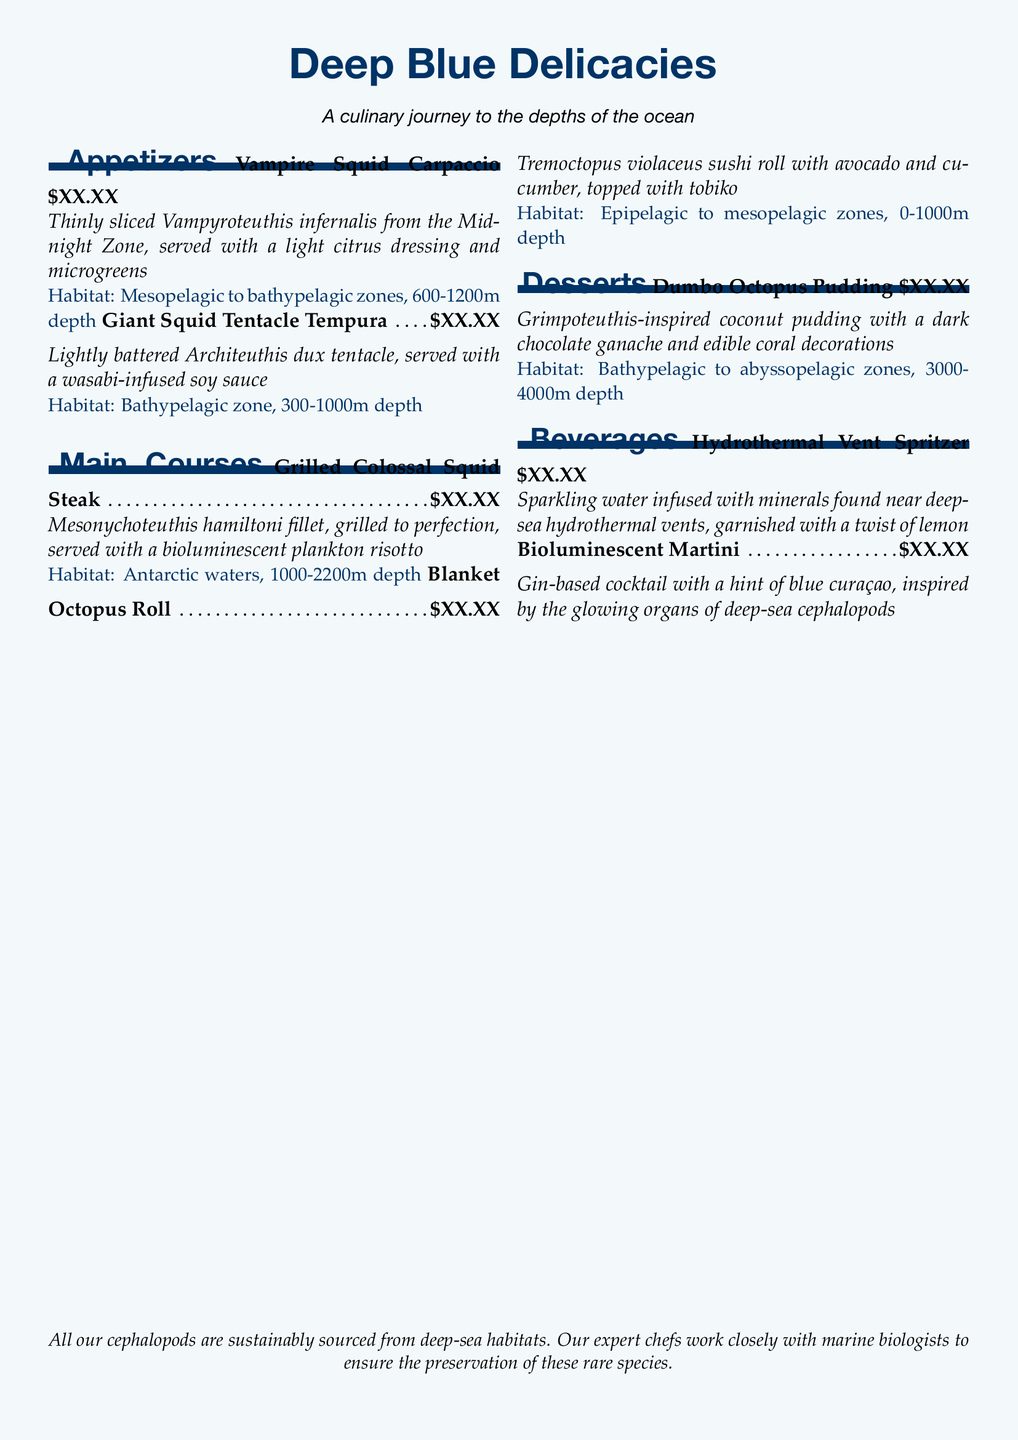What is the first appetizer listed on the menu? The first appetizer listed is "Vampire Squid Carpaccio."
Answer: Vampire Squid Carpaccio What is the primary habitat of the Giant Squid? The primary habitat of the Giant Squid is mentioned as "Bathypelagic zone, 300-1000m depth."
Answer: Bathypelagic zone, 300-1000m depth How many appetizers are there on the menu? There are two appetizers listed in the menu section.
Answer: 2 What dessert features ingredients inspired by a deep-sea cephalopod? The dessert "Dumbo Octopus Pudding" features ingredients inspired by a deep-sea cephalopod.
Answer: Dumbo Octopus Pudding What type of cuisine is represented by the menu? The menu represents a culinary journey focused on deep-sea delicacies.
Answer: Deep Blue Delicacies Which drink is inspired by deep-sea hydrothermal vents? The drink inspired by deep-sea hydrothermal vents is "Hydrothermal Vent Spritzer."
Answer: Hydrothermal Vent Spritzer What is served alongside the Grilled Colossal Squid Steak? The Grilled Colossal Squid Steak is served with a bioluminescent plankton risotto.
Answer: Bioluminescent plankton risotto How is the Vampire Squid Carpaccio prepared? The Vampire Squid Carpaccio is "Thinly sliced" and served with citrus dressing.
Answer: Thinly sliced What is the price format used in the menu? The price format used in the menu is denoted as "\$XX.XX."
Answer: \$XX.XX 